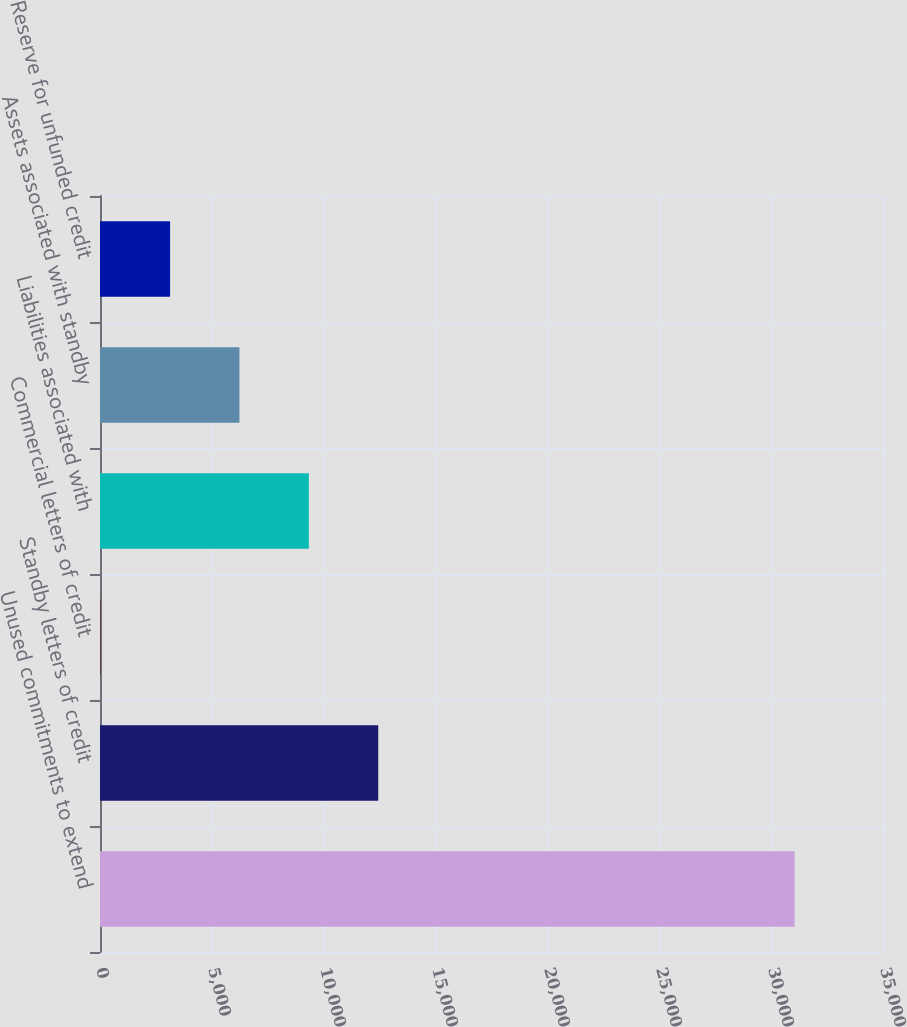Convert chart to OTSL. <chart><loc_0><loc_0><loc_500><loc_500><bar_chart><fcel>Unused commitments to extend<fcel>Standby letters of credit<fcel>Commercial letters of credit<fcel>Liabilities associated with<fcel>Assets associated with standby<fcel>Reserve for unfunded credit<nl><fcel>31008<fcel>12421.2<fcel>30<fcel>9323.4<fcel>6225.6<fcel>3127.8<nl></chart> 